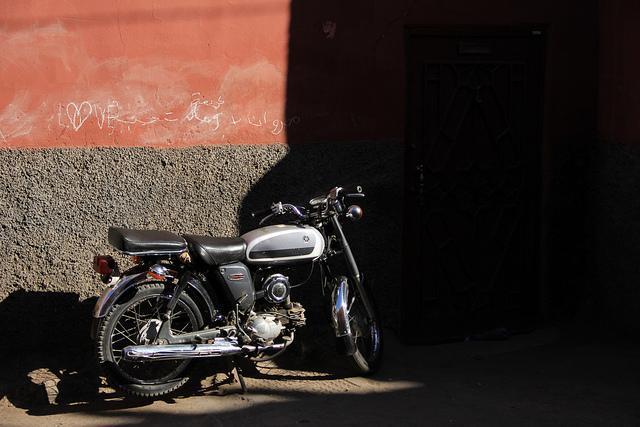How many people are on this motorcycle?
Give a very brief answer. 0. 